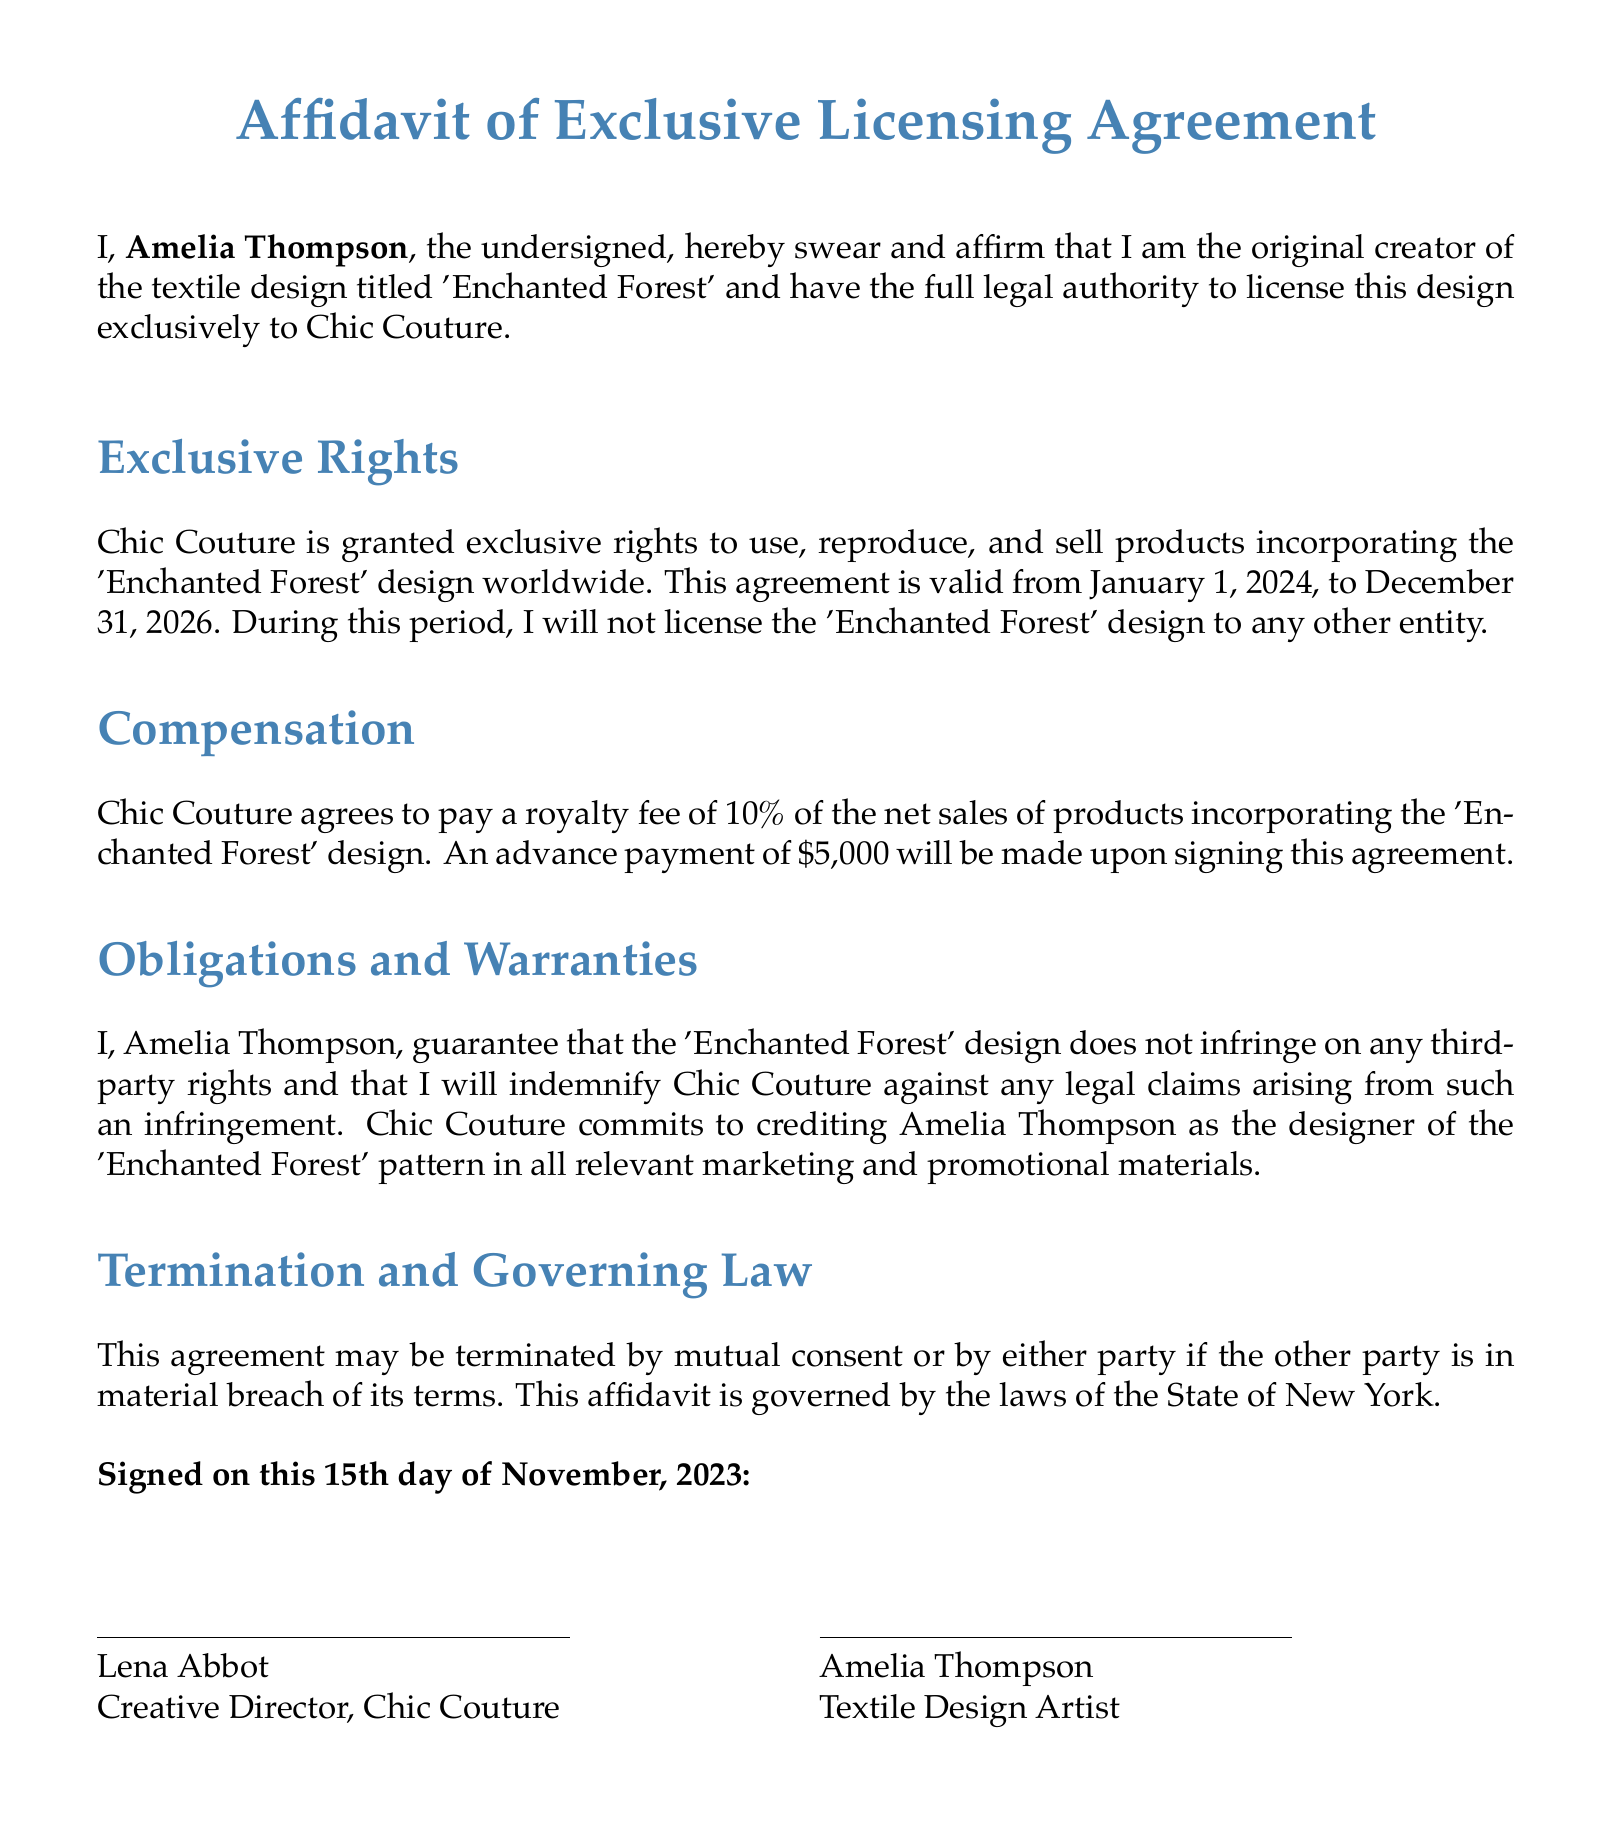What is the title of the textile design? The title of the textile design created by Amelia Thompson is stated in the document.
Answer: Enchanted Forest Who is the creator of the design? The document explicitly names the person who created the design.
Answer: Amelia Thompson What is the royalty fee percentage for Chic Couture? The document specifies the percentage of net sales that will be paid as a royalty fee.
Answer: 10% When does the exclusive agreement start? The document mentions the start date of the agreement for the exclusive rights.
Answer: January 1, 2024 What is the advance payment amount? The affidavit states the amount that will be paid in advance upon signing the agreement.
Answer: $5,000 Which state's law governs this agreement? The governing law mentioned in the document refers to the legal jurisdiction applicable to the agreement.
Answer: New York What is Amelia Thompson's guarantee related to the design? The document includes a guarantee about third-party rights regarding the textile design.
Answer: Non-infringement What is the duration of the exclusive rights? The agreement specifies the time period for which the exclusive rights are granted.
Answer: Three years 